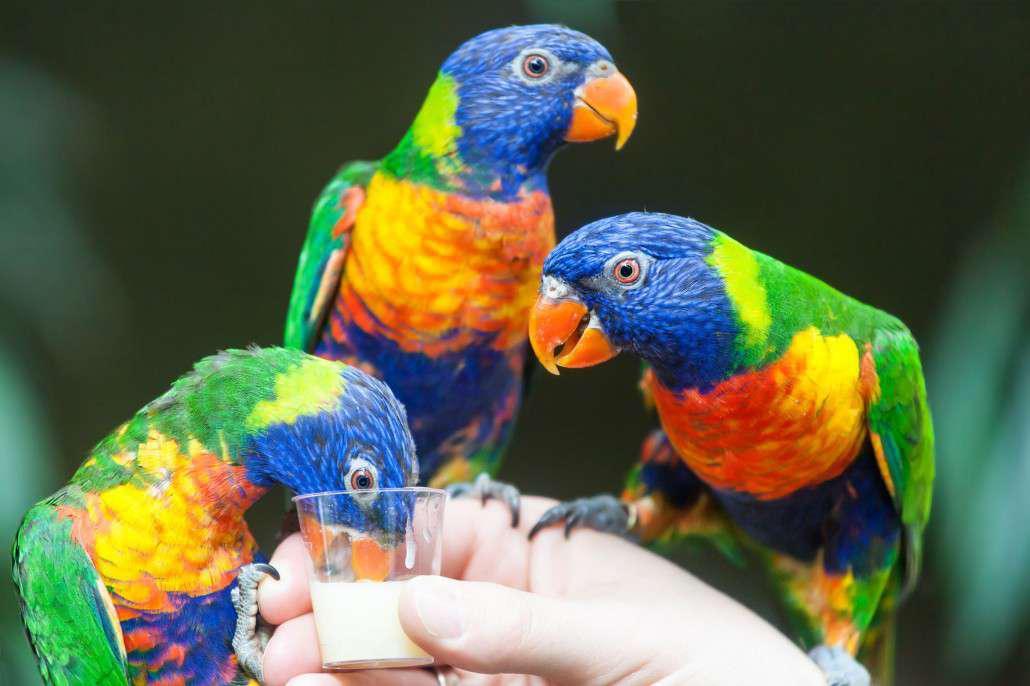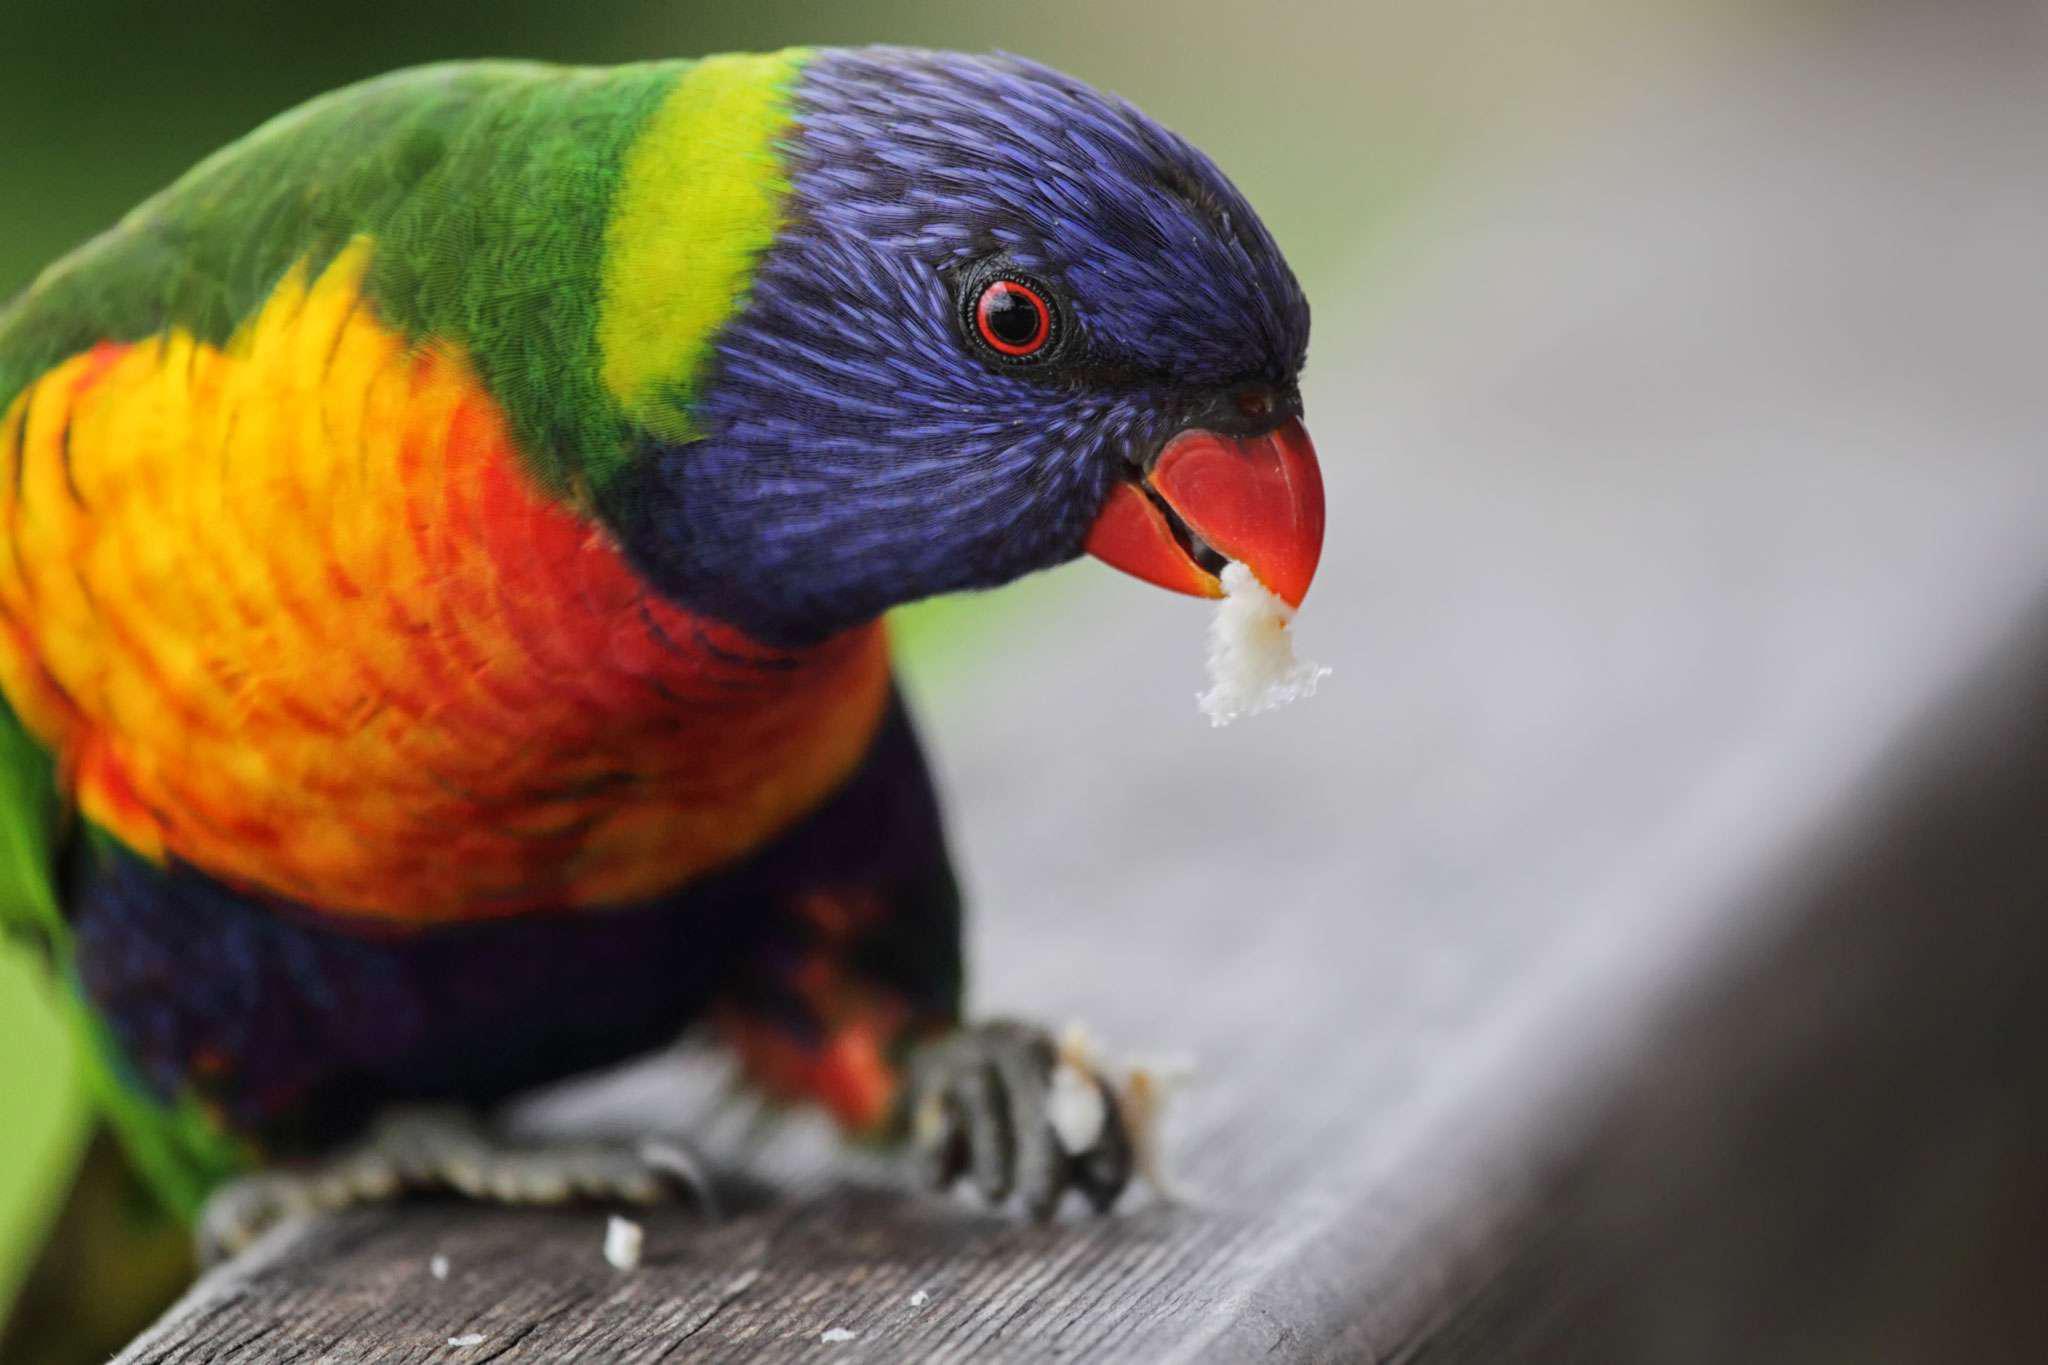The first image is the image on the left, the second image is the image on the right. Considering the images on both sides, is "The right hand image shows exactly two birds perched on the same branch and looking the same direction." valid? Answer yes or no. No. The first image is the image on the left, the second image is the image on the right. Analyze the images presented: Is the assertion "There are two birds in each image." valid? Answer yes or no. No. The first image is the image on the left, the second image is the image on the right. For the images shown, is this caption "the right image has two birds next to each other on a branch" true? Answer yes or no. No. The first image is the image on the left, the second image is the image on the right. Analyze the images presented: Is the assertion "There are exactly two parrots perched on a branch in the right image." valid? Answer yes or no. No. 